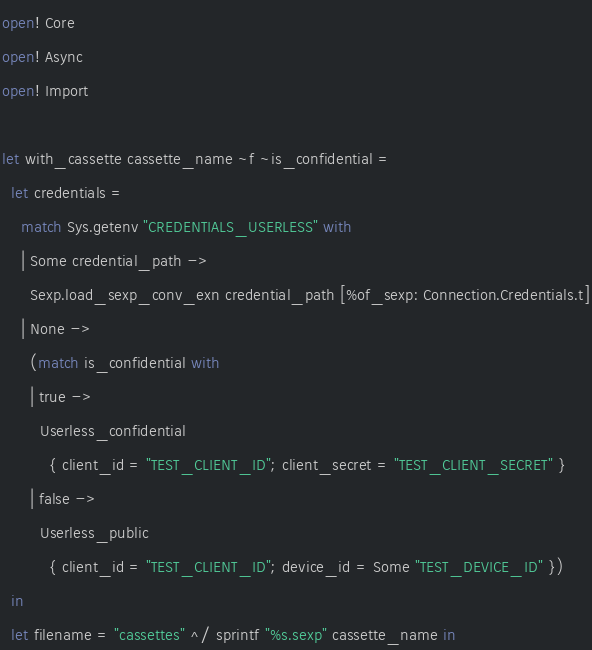Convert code to text. <code><loc_0><loc_0><loc_500><loc_500><_OCaml_>open! Core
open! Async
open! Import

let with_cassette cassette_name ~f ~is_confidential =
  let credentials =
    match Sys.getenv "CREDENTIALS_USERLESS" with
    | Some credential_path ->
      Sexp.load_sexp_conv_exn credential_path [%of_sexp: Connection.Credentials.t]
    | None ->
      (match is_confidential with
      | true ->
        Userless_confidential
          { client_id = "TEST_CLIENT_ID"; client_secret = "TEST_CLIENT_SECRET" }
      | false ->
        Userless_public
          { client_id = "TEST_CLIENT_ID"; device_id = Some "TEST_DEVICE_ID" })
  in
  let filename = "cassettes" ^/ sprintf "%s.sexp" cassette_name in</code> 